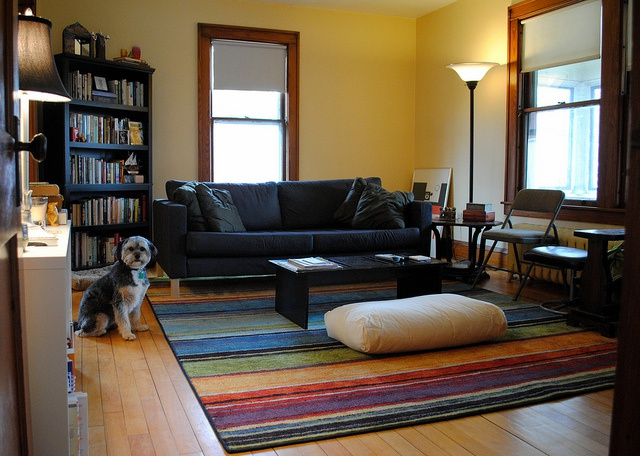Describe the objects in this image and their specific colors. I can see couch in black, blue, and gray tones, book in black, gray, and darkgray tones, dog in black, gray, darkgray, and maroon tones, chair in black, maroon, gray, and darkgray tones, and book in black, gray, and purple tones in this image. 